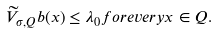<formula> <loc_0><loc_0><loc_500><loc_500>\widetilde { V } _ { \sigma , Q } b ( x ) \leq \lambda _ { 0 } f o r e v e r y x \in Q .</formula> 